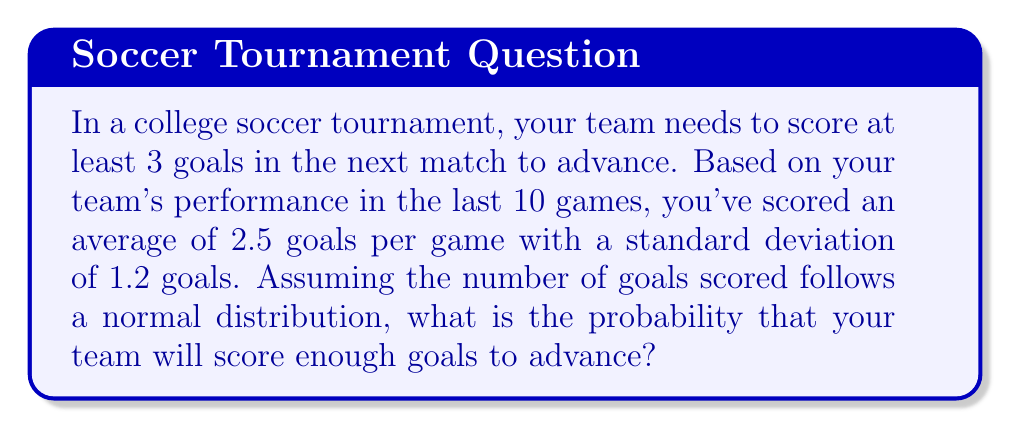Teach me how to tackle this problem. Let's approach this step-by-step:

1) We're dealing with a normal distribution where:
   Mean (μ) = 2.5 goals
   Standard deviation (σ) = 1.2 goals

2) We need to find P(X ≥ 3), where X is the number of goals scored.

3) To use the standard normal distribution, we need to calculate the z-score:

   $$z = \frac{x - \mu}{\sigma}$$

   Where x is the value we're interested in (3 goals).

4) Plugging in our values:

   $$z = \frac{3 - 2.5}{1.2} = \frac{0.5}{1.2} \approx 0.4167$$

5) Now we need to find P(Z ≥ 0.4167) using a standard normal table or calculator.

6) This is equivalent to 1 - P(Z < 0.4167)

7) Using a calculator or standard normal table, we find:
   P(Z < 0.4167) ≈ 0.6615

8) Therefore, P(Z ≥ 0.4167) = 1 - 0.6615 = 0.3385

9) Converting to a percentage: 0.3385 * 100 ≈ 33.85%
Answer: 33.85% 